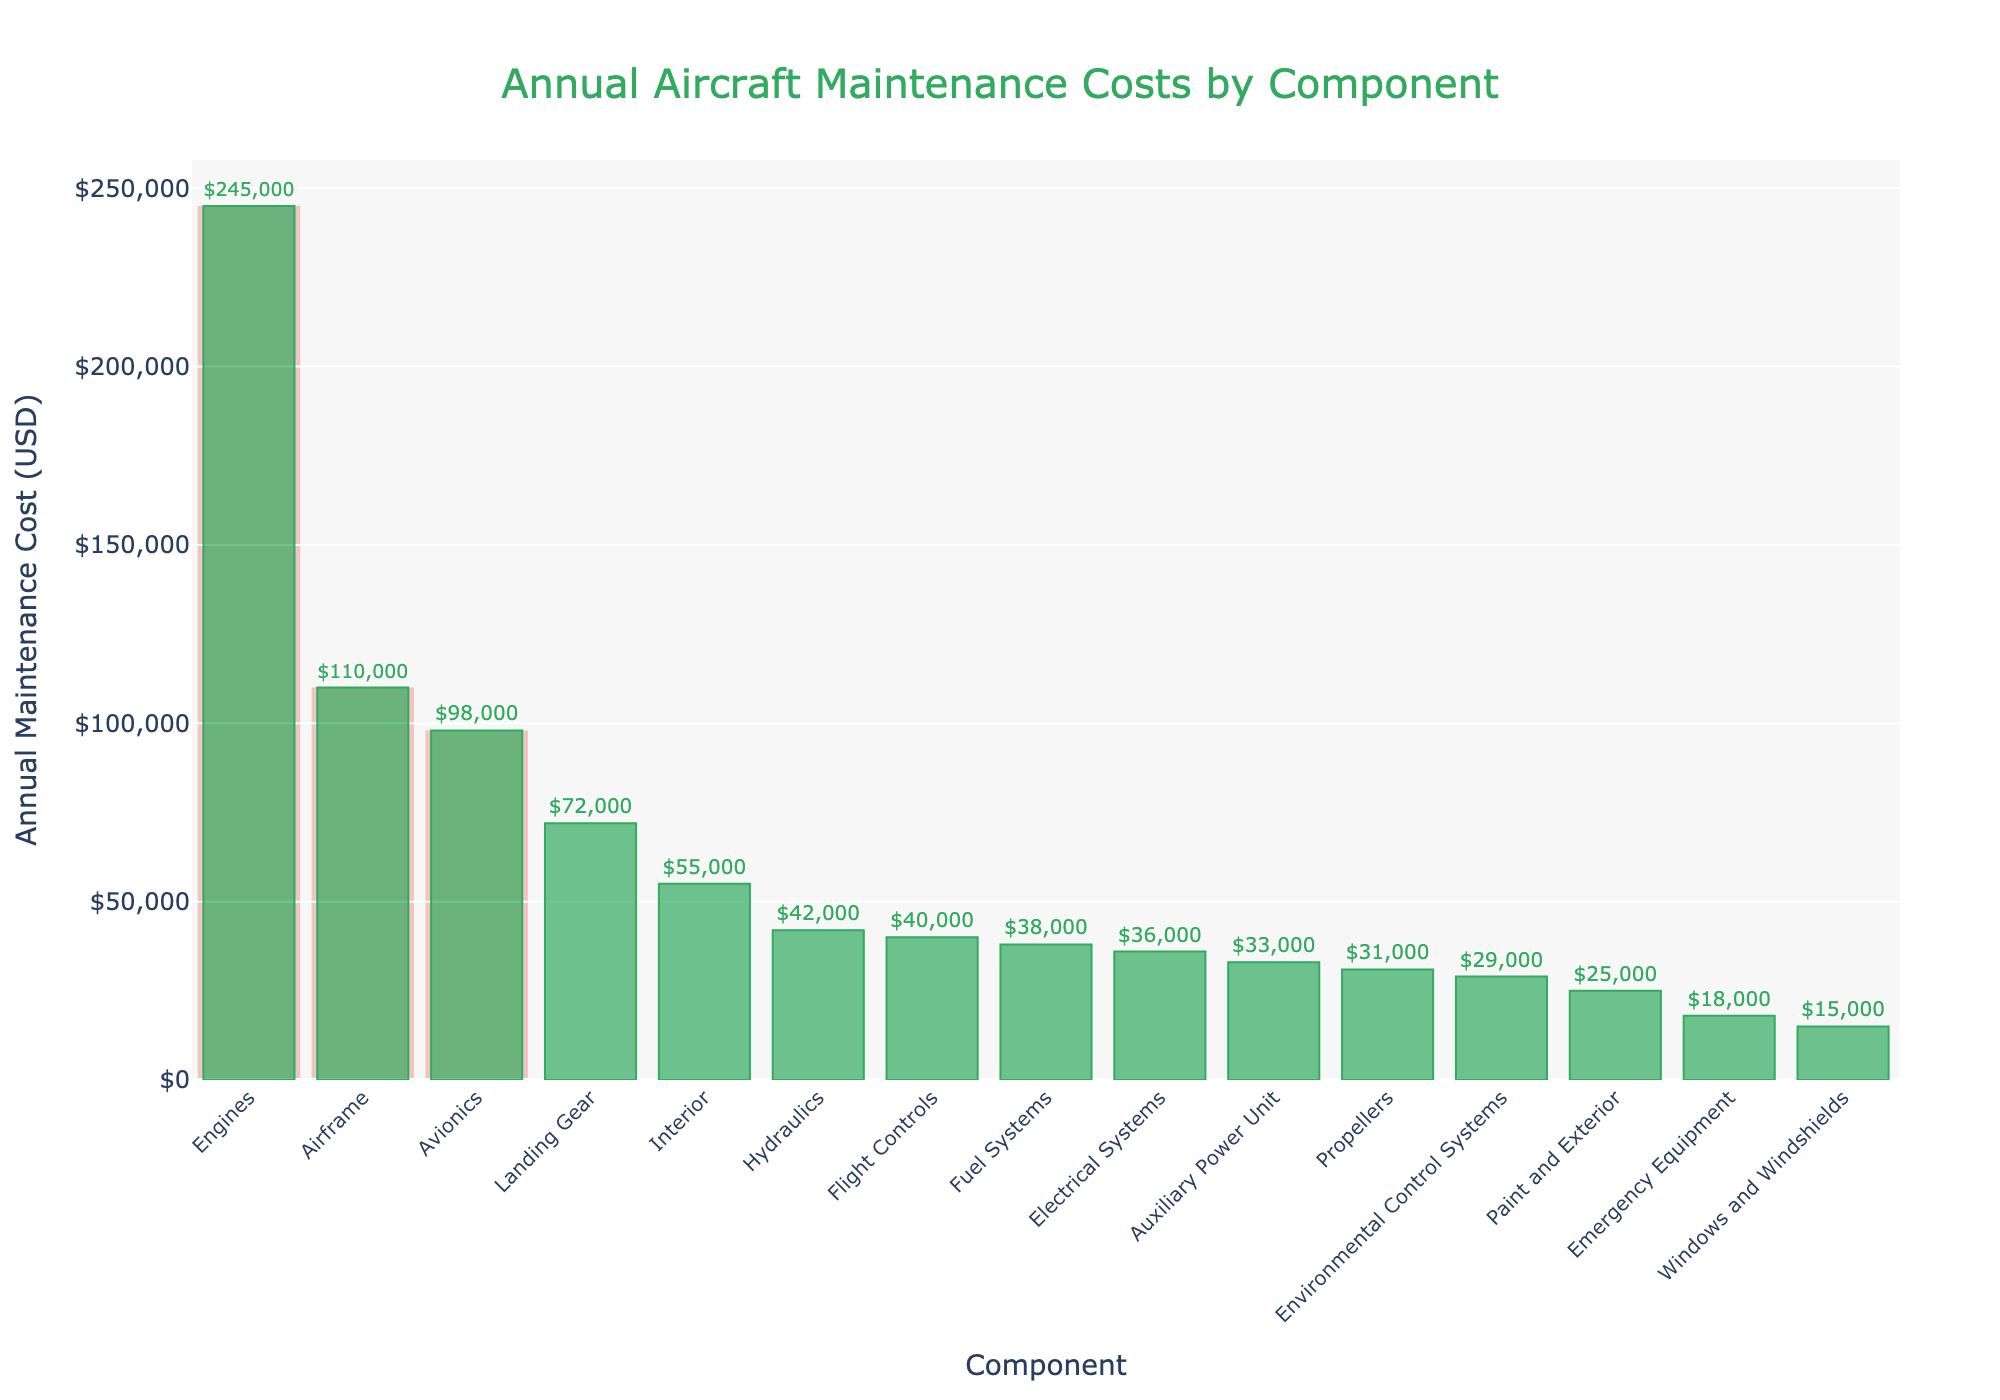Which component has the highest annual maintenance cost? The highest bar on the chart represents the component with the highest annual maintenance cost, which is "Engines."
Answer: Engines What is the combined annual maintenance cost of the top three components? The top three components are Engines, Airframe, and Avionics. Their combined cost is 245,000 + 110,000 + 98,000 = 453,000 USD.
Answer: 453,000 USD How many components have an annual maintenance cost greater than 50,000 USD? The bars with values greater than 50,000 USD are Engines, Airframe, Avionics, Landing Gear, and Interior. Counting these gives 5 components.
Answer: 5 How much more does maintaining the Engines cost compared to the Electrical Systems? The Engines cost 245,000 USD and the Electrical Systems cost 36,000 USD. The difference is 245,000 - 36,000 = 209,000 USD.
Answer: 209,000 USD Which component has a lower annual maintenance cost: Propellers or Fuel Systems? By comparing the height of the bars, we see that Propellers have a cost of 31,000 USD and Fuel Systems have a cost of 38,000 USD. Therefore, Propellers have a lower cost.
Answer: Propellers What is the average annual maintenance cost for the bottom three components? The bottom three components are Windows and Windshields, Paint and Exterior, and Emergency Equipment. Their costs are 15,000 + 25,000 + 18,000. The sum is 58,000, and the average is 58,000 / 3 = 19,333.33 USD.
Answer: 19,333.33 USD Which components fall within the maintenance cost range of 20,000 to 40,000 USD? The components with maintenance costs in this range are Propellers (31,000 USD), Flight Controls (40,000 USD), Interior (55,000 USD), Hydraulics (42,000 USD), Electrical Systems (36,000 USD), Environmental Control Systems (29,000 USD), and Paint and Exterior (25,000 USD).
Answer: Propellers, Flight Controls, Electrical Systems, Environmental Control Systems, Paint and Exterior Is the maintenance cost of the Avionics closer to that of the Airframe or Landing Gear? The Avionics cost 98,000 USD, the Airframe costs 110,000 USD, and the Landing Gear costs 72,000 USD. The difference between Avionics and Airframe is 110,000 - 98,000 = 12,000 USD, while the difference between Avionics and Landing Gear is 98,000 - 72,000 = 26,000 USD. Avionics is closer to Airframe.
Answer: Airframe 